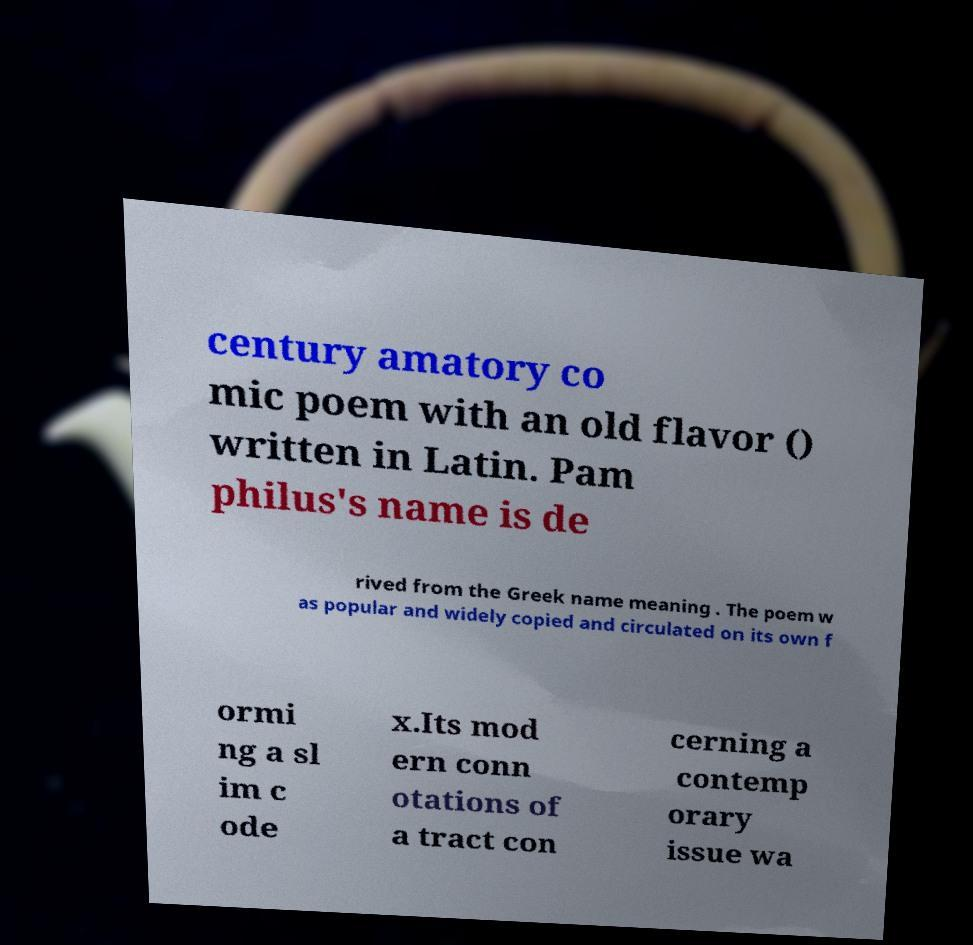Could you assist in decoding the text presented in this image and type it out clearly? century amatory co mic poem with an old flavor () written in Latin. Pam philus's name is de rived from the Greek name meaning . The poem w as popular and widely copied and circulated on its own f ormi ng a sl im c ode x.Its mod ern conn otations of a tract con cerning a contemp orary issue wa 